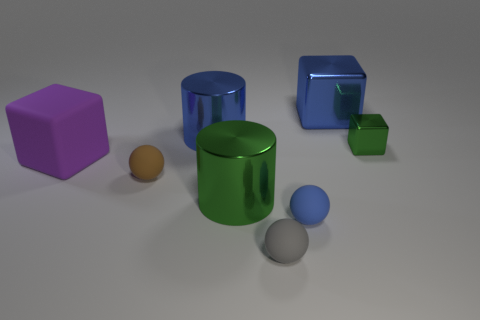Add 1 green things. How many objects exist? 9 Subtract all balls. How many objects are left? 5 Subtract 0 brown cylinders. How many objects are left? 8 Subtract all green metal balls. Subtract all tiny metal blocks. How many objects are left? 7 Add 2 big blue blocks. How many big blue blocks are left? 3 Add 5 purple metal objects. How many purple metal objects exist? 5 